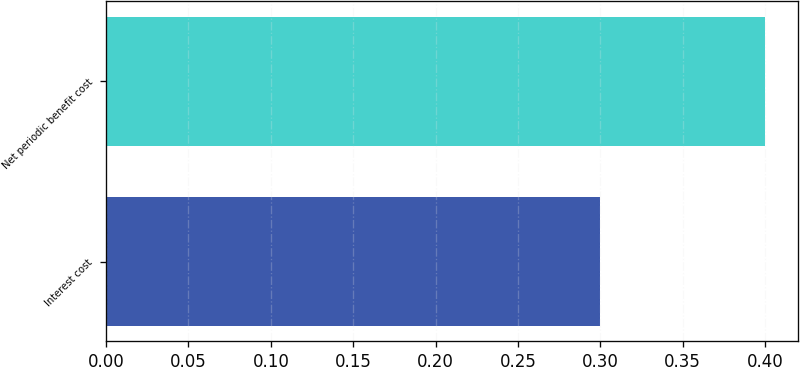<chart> <loc_0><loc_0><loc_500><loc_500><bar_chart><fcel>Interest cost<fcel>Net periodic benefit cost<nl><fcel>0.3<fcel>0.4<nl></chart> 